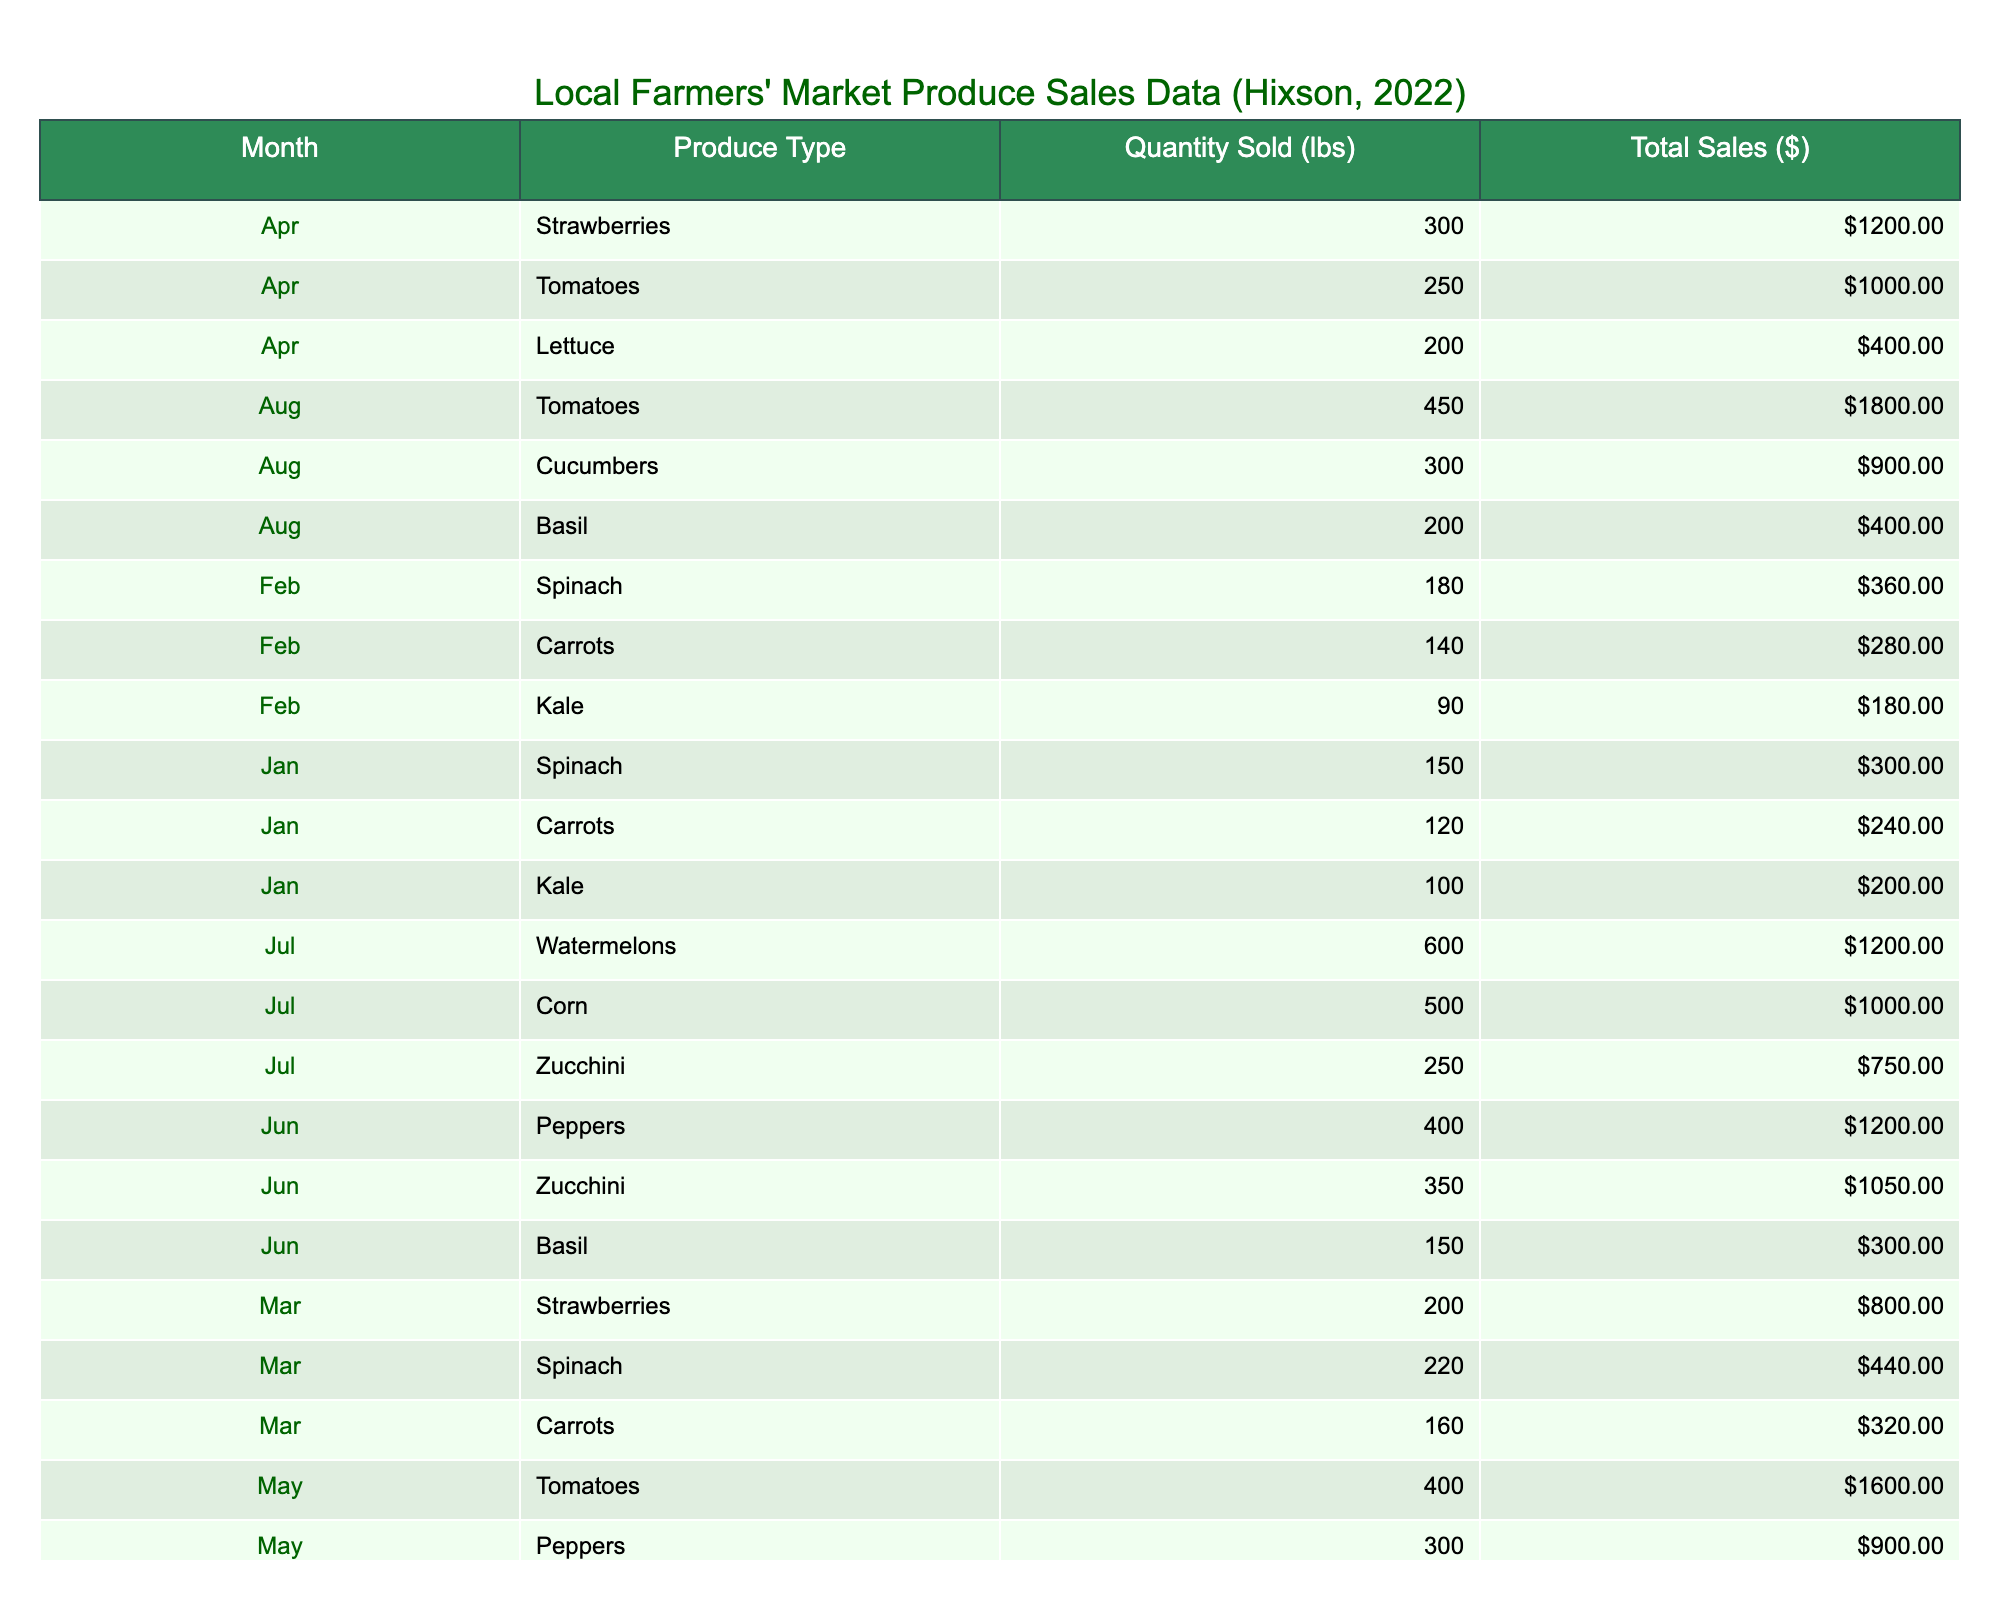What was the total quantity of tomatoes sold in April? In April, the table shows that 250 lbs of tomatoes were sold. Thus, the total quantity of tomatoes sold in that month is directly given as 250 lbs.
Answer: 250 lbs Which produce had the highest total sales in August? According to the table, the produce with the highest total sales in August is tomatoes, with total sales amounting to $1800.
Answer: Tomatoes What was the average quantity sold for carrots across the months? The quantities sold for carrots are 120 in January, 140 in February, 160 in March, 350 in September. Adding these gives 120 + 140 + 160 + 350 = 770 lbs. We then divide by the number of months (4) to get 770 / 4 = 192.5 lbs.
Answer: 192.5 lbs Did sales of zucchinis exceed 1000 dollars in June? In June, the table indicates zucchinis generated total sales of $1050. Since this is above $1000, the answer is yes.
Answer: Yes What produce type had the least sales in October? In October, the table displays sales of pumpkins totaling $400, kale totaling $300, and apples totaling $1200. Since $300 (kale) is less than both $400 and $1200, kale has the least sales in October.
Answer: Kale What was the total sales for all types of berries (strawberries and blueberries) in March and April? In March, the total sales for strawberries was $800, and in April, strawberries totaled $1200. The table shows no blueberries. Therefore, total sales for berries across the months would be $800 + $1200 = $2000.
Answer: $2000 Which month had the highest total sales for all produce combined? To find the month with the highest total sales, we can sum up total sales for each month. The highest total from summing shows July had total sales of $2950, which is greater than any other month.
Answer: July Did the sales of spinach increase every month starting from January through March? Reviewing the table, spinach sales were 150 lbs in January, increased to 180 lbs in February, and further increased to 220 lbs in March. This confirms a continuous increase in spinach sales during these months.
Answer: Yes 